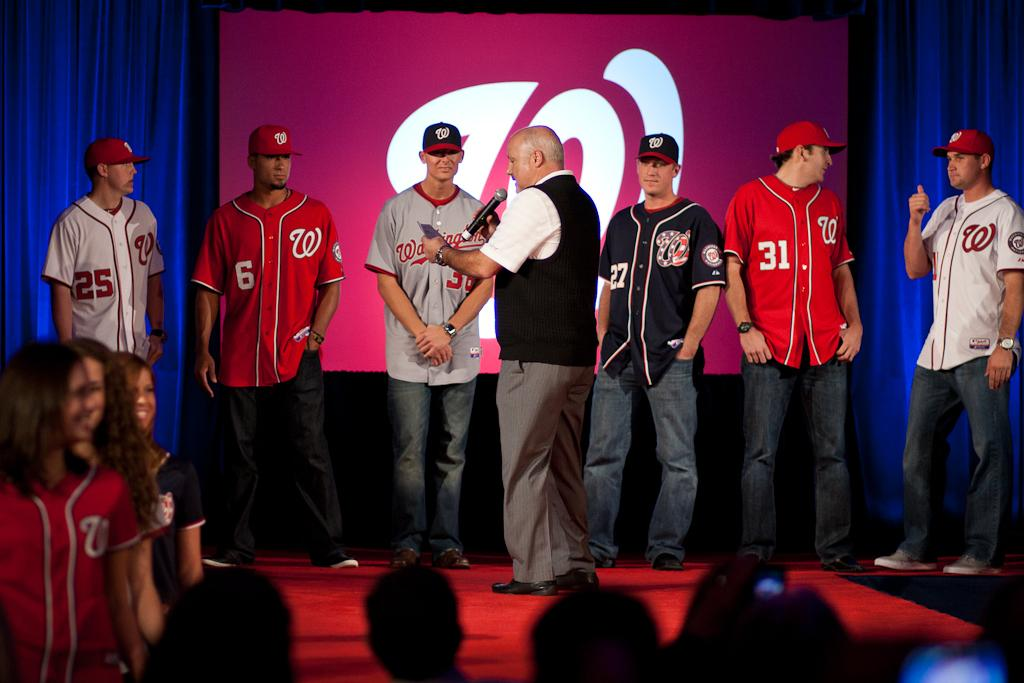<image>
Present a compact description of the photo's key features. a player has the number 31 on their jersey 